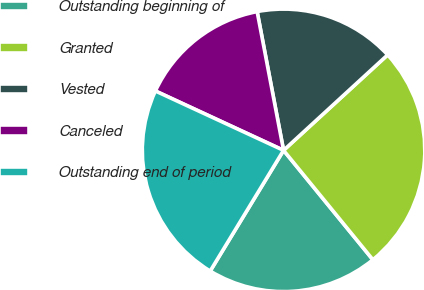<chart> <loc_0><loc_0><loc_500><loc_500><pie_chart><fcel>Outstanding beginning of<fcel>Granted<fcel>Vested<fcel>Canceled<fcel>Outstanding end of period<nl><fcel>19.59%<fcel>25.91%<fcel>16.18%<fcel>15.1%<fcel>23.21%<nl></chart> 